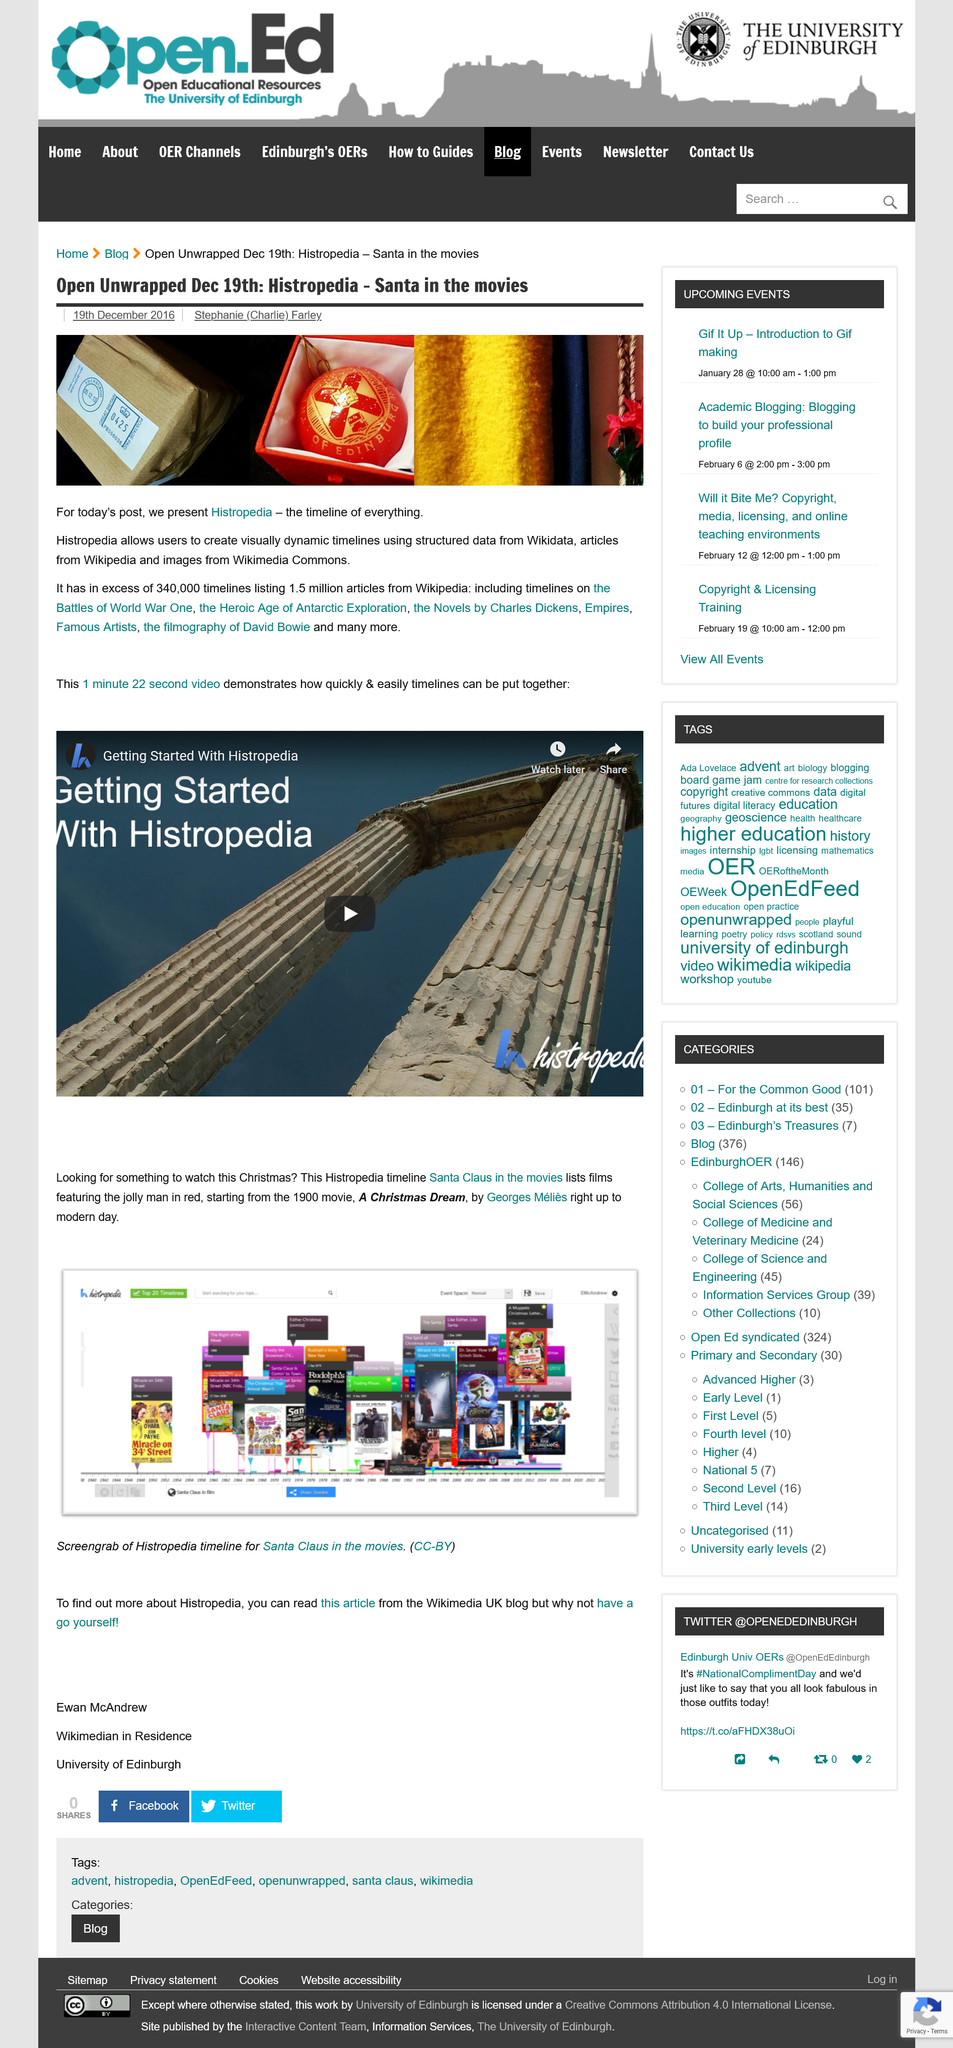Point out several critical features in this image. The author of the article "Open Unwrapped Dec 19th: Histropedia - Santa in the movies" is Stephanie (Charlie) Farley. Histropedia has more than 340,000 timelines, which exceeds the number of timelines in any other virtual world. The video demonstrating how quickly and easily timelines can be put together is 1 minute and 22 seconds long, and it shows how to create a timeline in a short amount of time. 